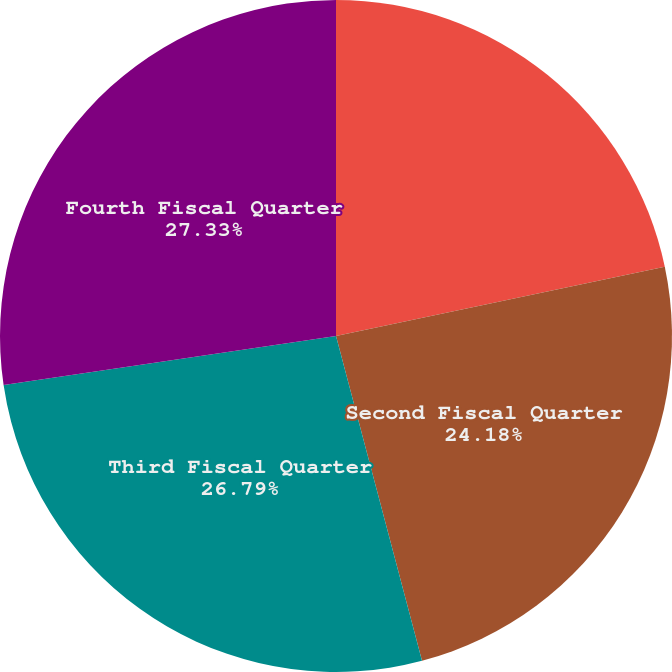Convert chart. <chart><loc_0><loc_0><loc_500><loc_500><pie_chart><fcel>First Fiscal Quarter<fcel>Second Fiscal Quarter<fcel>Third Fiscal Quarter<fcel>Fourth Fiscal Quarter<nl><fcel>21.7%<fcel>24.18%<fcel>26.79%<fcel>27.33%<nl></chart> 